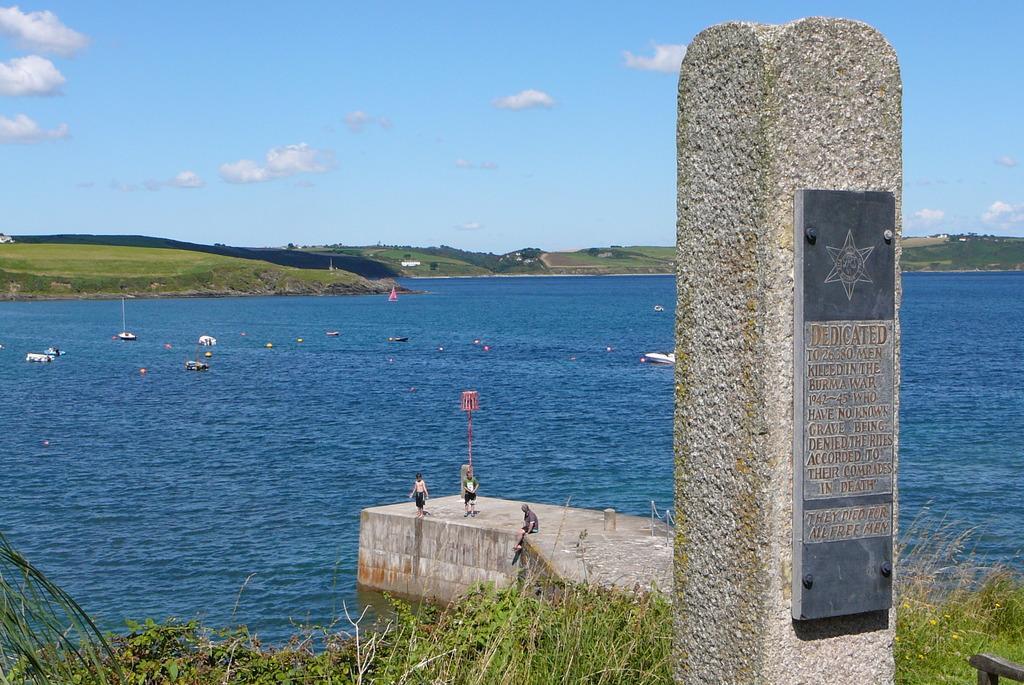In one or two sentences, can you explain what this image depicts? This picture is taken beside the river. On the river, there are boats. Beside the river, there is a concrete bridge. On the bridge, there are three people. Towards the right, there is a stone with a board and some text engraved on it. At the bottom, there are plants and grass. In the background, there are hills and a sky with clouds. 